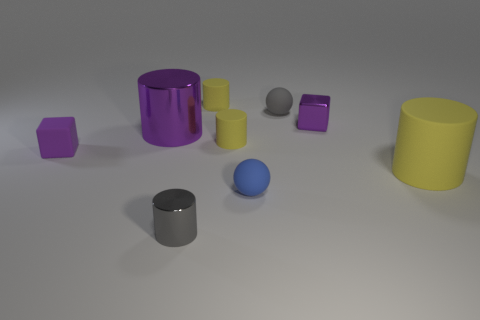What is the color of the big cylinder that is behind the purple cube that is in front of the purple metal object left of the gray metal object?
Give a very brief answer. Purple. Is there anything else that has the same shape as the large purple shiny object?
Provide a short and direct response. Yes. Is the number of big purple cylinders greater than the number of red shiny blocks?
Your answer should be very brief. Yes. How many rubber things are both in front of the purple rubber block and behind the tiny blue rubber ball?
Provide a short and direct response. 1. There is a gray thing that is to the left of the blue object; what number of objects are in front of it?
Give a very brief answer. 0. Do the sphere that is behind the purple cylinder and the purple shiny thing left of the blue object have the same size?
Offer a terse response. No. How many small purple metal cylinders are there?
Your response must be concise. 0. How many big purple objects are the same material as the gray ball?
Give a very brief answer. 0. Is the number of yellow things that are right of the tiny shiny cylinder the same as the number of gray metal cylinders?
Offer a very short reply. No. There is a cylinder that is the same color as the metallic block; what is it made of?
Your answer should be compact. Metal. 